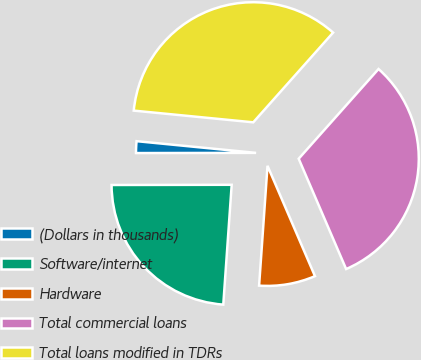Convert chart. <chart><loc_0><loc_0><loc_500><loc_500><pie_chart><fcel>(Dollars in thousands)<fcel>Software/internet<fcel>Hardware<fcel>Total commercial loans<fcel>Total loans modified in TDRs<nl><fcel>1.58%<fcel>23.86%<fcel>7.58%<fcel>31.96%<fcel>35.02%<nl></chart> 